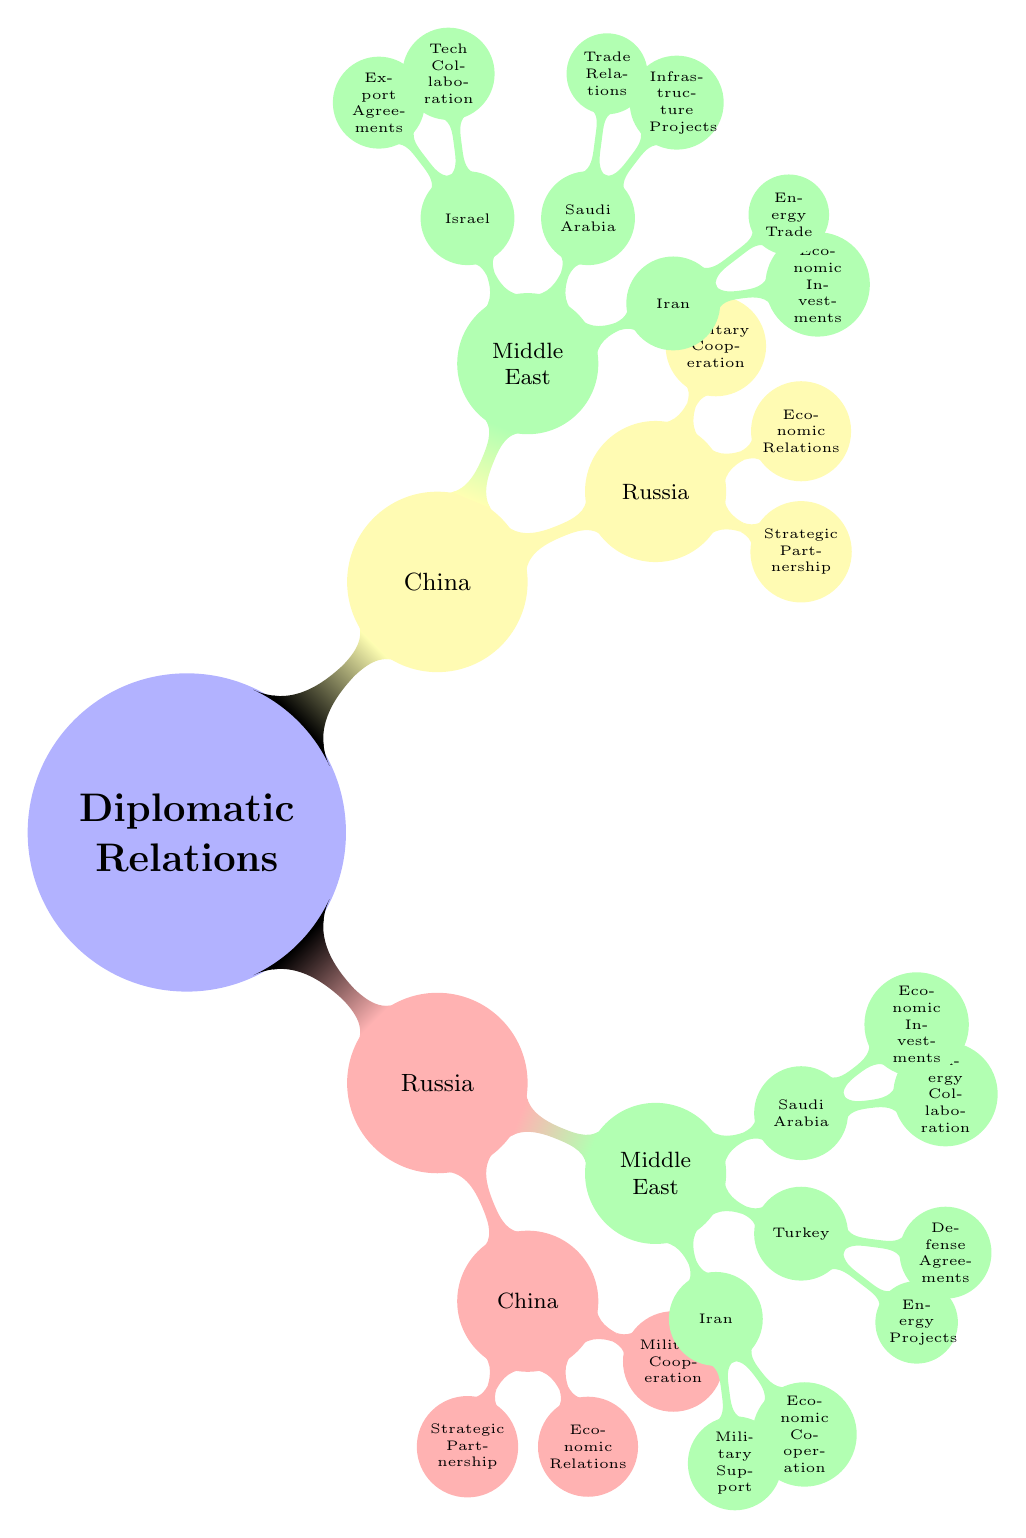What type of partnership exists between Russia and China? The diagram indicates that the relationship is a "Comprehensive Strategic Partnership" under the Russia to China branch. This is clearly labeled as a node in that section.
Answer: Comprehensive Strategic Partnership How many countries in the Middle East are involved in Russia's diplomatic relations? By examining the Middle East branch of Russia, there are three specific nodes labeled: Iran, Turkey, and Saudi Arabia. Hence, the total is three.
Answer: 3 What military asset did Russia sell to Turkey? The diagram specifies "S-400 Missile System Sale" as the military agreement made between Russia and Turkey, clearly indicated in their respective node.
Answer: S-400 Missile System Sale What initiative do China and Iran collaborate on? In the China-Iran section, the diagram shows "Belt and Road Initiative Projects" as the main area of collaboration, making it clear what's being worked on together.
Answer: Belt and Road Initiative Projects Which Middle Eastern country has a tech collaboration with China? The diagram outlines that Israel is the Middle Eastern country involved in "Tech Collaboration" with China, which is specifically mentioned under their relationship node.
Answer: Israel What type of energy agreement exists between Russia and Saudi Arabia? The diagram indicates that within their node, the relationship is characterized by "Oil Export Agreements," revealing how they collaborate in the energy sector.
Answer: Oil Export Agreements How many agreements or collaborations does China have with Iran according to the diagram? The diagram lists two specific areas of collaboration between China and Iran: Economic Investments and Energy Trade. Therefore, the total number is two.
Answer: 2 What is one of the energy projects that Russia is involved in with Turkey? The diagram directly mentions "TurkStream Pipeline" as an energy project involving Turkey under the Russia-Middle East branch, clearly indicating this partnership.
Answer: TurkStream Pipeline What is the nature of economic interactions between Russia and Saudi Arabia? The diagram describes the relationship in terms of "Joint Ventures in Nuclear and Mining" as well as "Energy Collaboration," indicating two distinct areas of economic interaction.
Answer: Joint Ventures in Nuclear and Mining, Energy Collaboration 